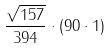Convert formula to latex. <formula><loc_0><loc_0><loc_500><loc_500>\frac { \sqrt { 1 5 7 } } { 3 9 4 } \cdot ( 9 0 \cdot 1 )</formula> 